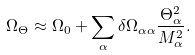Convert formula to latex. <formula><loc_0><loc_0><loc_500><loc_500>\Omega _ { \Theta } \approx \Omega _ { 0 } + \sum _ { \alpha } \delta \Omega _ { \alpha \alpha } \frac { \Theta _ { \alpha } ^ { 2 } } { M _ { \alpha } ^ { 2 } } .</formula> 